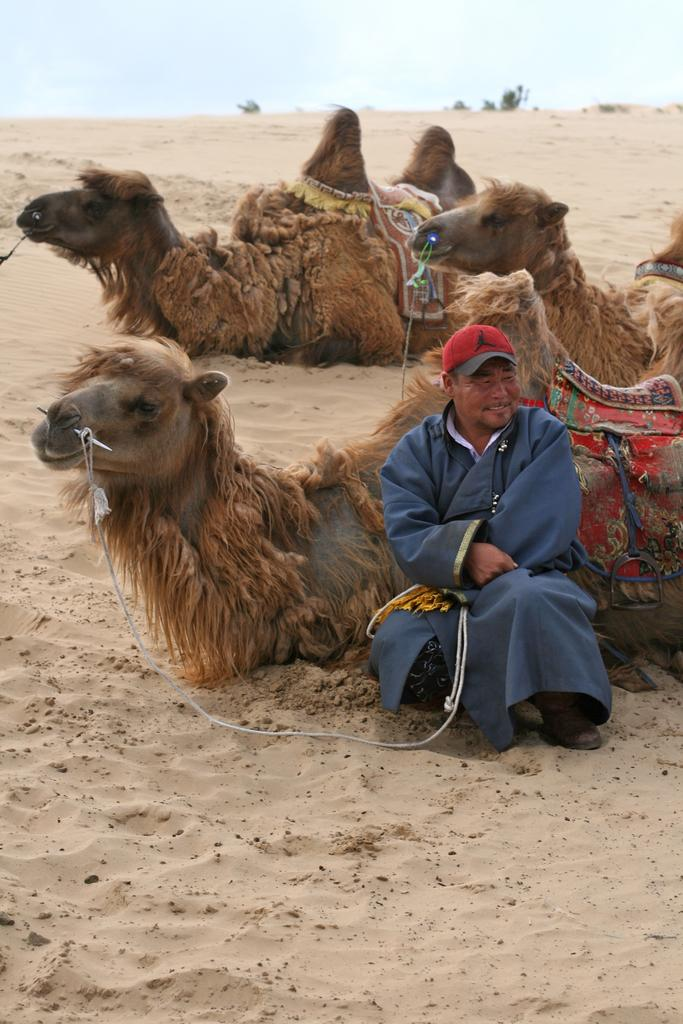What is the main subject of the image? There is a person sitting in the image. What other subjects are present in the image? There are camels sitting on the sand in the image. What can be seen in the background of the image? The sky is visible at the top of the image. What type of eggnog is being prepared by the cook in the image? There is no cook or eggnog present in the image; it features a person sitting and camels on the sand. What kind of apparatus is being used by the person in the image? There is no apparatus visible in the image; the person is simply sitting. 